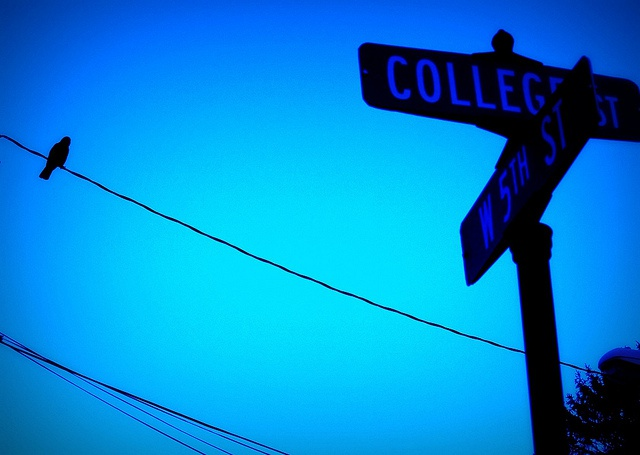Describe the objects in this image and their specific colors. I can see a bird in darkblue, black, lightblue, blue, and navy tones in this image. 